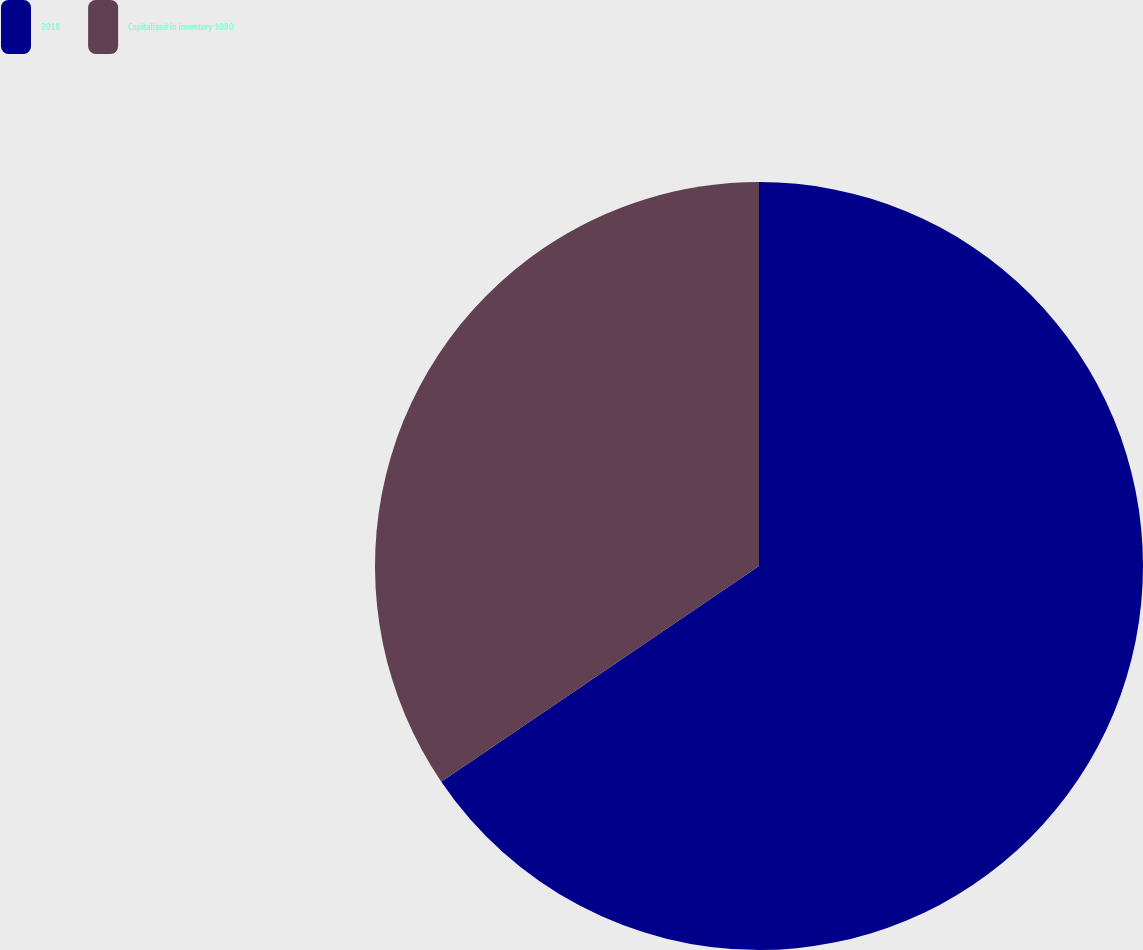Convert chart to OTSL. <chart><loc_0><loc_0><loc_500><loc_500><pie_chart><fcel>2018<fcel>Capitalized in inventory 1080<nl><fcel>65.51%<fcel>34.49%<nl></chart> 